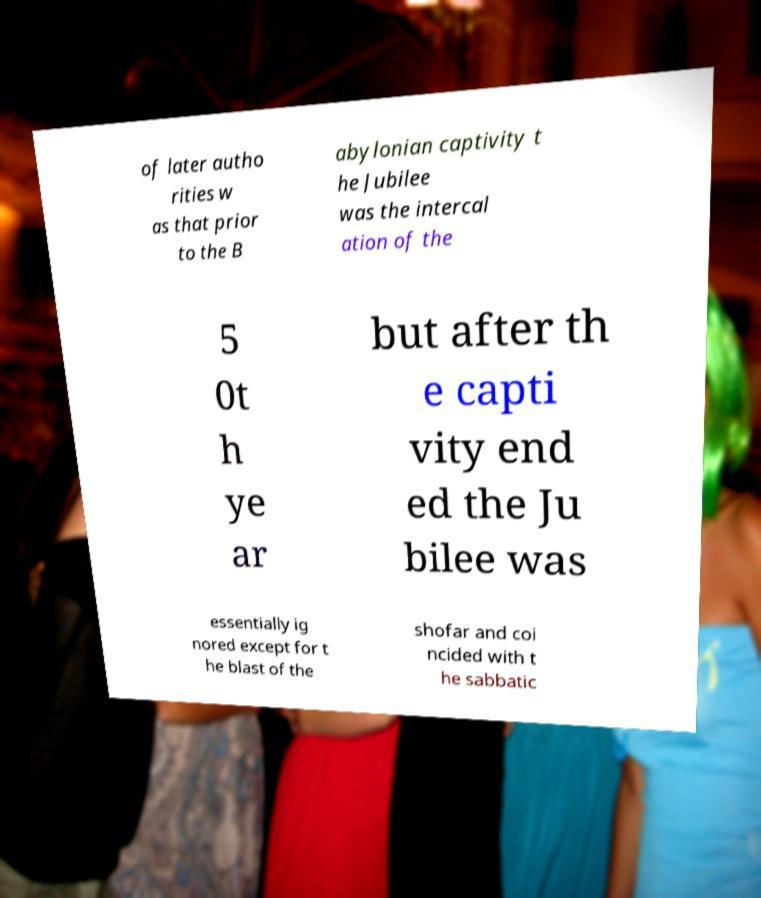For documentation purposes, I need the text within this image transcribed. Could you provide that? of later autho rities w as that prior to the B abylonian captivity t he Jubilee was the intercal ation of the 5 0t h ye ar but after th e capti vity end ed the Ju bilee was essentially ig nored except for t he blast of the shofar and coi ncided with t he sabbatic 